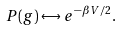<formula> <loc_0><loc_0><loc_500><loc_500>P ( g ) \leftrightarrow e ^ { - \beta V / 2 } .</formula> 